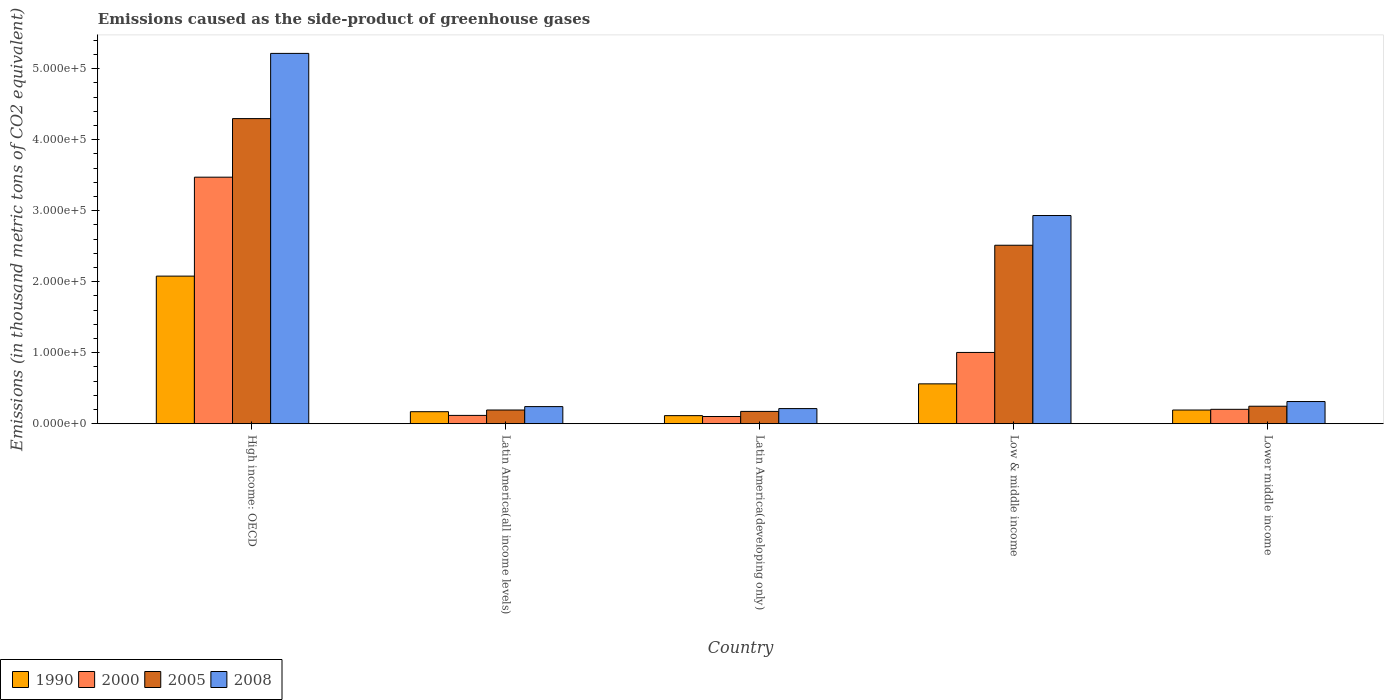How many bars are there on the 1st tick from the left?
Your response must be concise. 4. What is the label of the 3rd group of bars from the left?
Keep it short and to the point. Latin America(developing only). In how many cases, is the number of bars for a given country not equal to the number of legend labels?
Your answer should be very brief. 0. What is the emissions caused as the side-product of greenhouse gases in 2000 in Low & middle income?
Provide a succinct answer. 1.00e+05. Across all countries, what is the maximum emissions caused as the side-product of greenhouse gases in 2000?
Offer a very short reply. 3.47e+05. Across all countries, what is the minimum emissions caused as the side-product of greenhouse gases in 1990?
Keep it short and to the point. 1.14e+04. In which country was the emissions caused as the side-product of greenhouse gases in 1990 maximum?
Offer a terse response. High income: OECD. In which country was the emissions caused as the side-product of greenhouse gases in 1990 minimum?
Ensure brevity in your answer.  Latin America(developing only). What is the total emissions caused as the side-product of greenhouse gases in 2005 in the graph?
Offer a very short reply. 7.42e+05. What is the difference between the emissions caused as the side-product of greenhouse gases in 2005 in High income: OECD and that in Lower middle income?
Your answer should be very brief. 4.05e+05. What is the difference between the emissions caused as the side-product of greenhouse gases in 2008 in Latin America(developing only) and the emissions caused as the side-product of greenhouse gases in 2005 in High income: OECD?
Your answer should be compact. -4.08e+05. What is the average emissions caused as the side-product of greenhouse gases in 2005 per country?
Give a very brief answer. 1.48e+05. What is the difference between the emissions caused as the side-product of greenhouse gases of/in 2005 and emissions caused as the side-product of greenhouse gases of/in 1990 in Latin America(developing only)?
Ensure brevity in your answer.  5959.2. What is the ratio of the emissions caused as the side-product of greenhouse gases in 1990 in Latin America(all income levels) to that in Low & middle income?
Your answer should be very brief. 0.3. Is the emissions caused as the side-product of greenhouse gases in 1990 in High income: OECD less than that in Latin America(all income levels)?
Provide a succinct answer. No. What is the difference between the highest and the second highest emissions caused as the side-product of greenhouse gases in 2005?
Provide a short and direct response. -2.27e+05. What is the difference between the highest and the lowest emissions caused as the side-product of greenhouse gases in 2008?
Provide a succinct answer. 5.00e+05. In how many countries, is the emissions caused as the side-product of greenhouse gases in 2005 greater than the average emissions caused as the side-product of greenhouse gases in 2005 taken over all countries?
Offer a terse response. 2. How many bars are there?
Keep it short and to the point. 20. Are all the bars in the graph horizontal?
Make the answer very short. No. What is the difference between two consecutive major ticks on the Y-axis?
Keep it short and to the point. 1.00e+05. Are the values on the major ticks of Y-axis written in scientific E-notation?
Ensure brevity in your answer.  Yes. Does the graph contain grids?
Provide a short and direct response. No. How many legend labels are there?
Provide a short and direct response. 4. What is the title of the graph?
Your response must be concise. Emissions caused as the side-product of greenhouse gases. What is the label or title of the X-axis?
Offer a very short reply. Country. What is the label or title of the Y-axis?
Offer a terse response. Emissions (in thousand metric tons of CO2 equivalent). What is the Emissions (in thousand metric tons of CO2 equivalent) of 1990 in High income: OECD?
Your answer should be compact. 2.08e+05. What is the Emissions (in thousand metric tons of CO2 equivalent) of 2000 in High income: OECD?
Offer a terse response. 3.47e+05. What is the Emissions (in thousand metric tons of CO2 equivalent) of 2005 in High income: OECD?
Keep it short and to the point. 4.30e+05. What is the Emissions (in thousand metric tons of CO2 equivalent) in 2008 in High income: OECD?
Give a very brief answer. 5.22e+05. What is the Emissions (in thousand metric tons of CO2 equivalent) of 1990 in Latin America(all income levels)?
Give a very brief answer. 1.70e+04. What is the Emissions (in thousand metric tons of CO2 equivalent) of 2000 in Latin America(all income levels)?
Offer a very short reply. 1.18e+04. What is the Emissions (in thousand metric tons of CO2 equivalent) in 2005 in Latin America(all income levels)?
Ensure brevity in your answer.  1.93e+04. What is the Emissions (in thousand metric tons of CO2 equivalent) in 2008 in Latin America(all income levels)?
Keep it short and to the point. 2.41e+04. What is the Emissions (in thousand metric tons of CO2 equivalent) in 1990 in Latin America(developing only)?
Your response must be concise. 1.14e+04. What is the Emissions (in thousand metric tons of CO2 equivalent) of 2000 in Latin America(developing only)?
Give a very brief answer. 1.02e+04. What is the Emissions (in thousand metric tons of CO2 equivalent) of 2005 in Latin America(developing only)?
Your response must be concise. 1.74e+04. What is the Emissions (in thousand metric tons of CO2 equivalent) of 2008 in Latin America(developing only)?
Your answer should be compact. 2.13e+04. What is the Emissions (in thousand metric tons of CO2 equivalent) of 1990 in Low & middle income?
Your response must be concise. 5.62e+04. What is the Emissions (in thousand metric tons of CO2 equivalent) of 2000 in Low & middle income?
Ensure brevity in your answer.  1.00e+05. What is the Emissions (in thousand metric tons of CO2 equivalent) of 2005 in Low & middle income?
Give a very brief answer. 2.51e+05. What is the Emissions (in thousand metric tons of CO2 equivalent) in 2008 in Low & middle income?
Provide a short and direct response. 2.93e+05. What is the Emissions (in thousand metric tons of CO2 equivalent) in 1990 in Lower middle income?
Provide a succinct answer. 1.93e+04. What is the Emissions (in thousand metric tons of CO2 equivalent) in 2000 in Lower middle income?
Provide a short and direct response. 2.03e+04. What is the Emissions (in thousand metric tons of CO2 equivalent) in 2005 in Lower middle income?
Your response must be concise. 2.47e+04. What is the Emissions (in thousand metric tons of CO2 equivalent) of 2008 in Lower middle income?
Give a very brief answer. 3.13e+04. Across all countries, what is the maximum Emissions (in thousand metric tons of CO2 equivalent) of 1990?
Give a very brief answer. 2.08e+05. Across all countries, what is the maximum Emissions (in thousand metric tons of CO2 equivalent) of 2000?
Your answer should be very brief. 3.47e+05. Across all countries, what is the maximum Emissions (in thousand metric tons of CO2 equivalent) of 2005?
Provide a succinct answer. 4.30e+05. Across all countries, what is the maximum Emissions (in thousand metric tons of CO2 equivalent) of 2008?
Ensure brevity in your answer.  5.22e+05. Across all countries, what is the minimum Emissions (in thousand metric tons of CO2 equivalent) in 1990?
Give a very brief answer. 1.14e+04. Across all countries, what is the minimum Emissions (in thousand metric tons of CO2 equivalent) in 2000?
Ensure brevity in your answer.  1.02e+04. Across all countries, what is the minimum Emissions (in thousand metric tons of CO2 equivalent) of 2005?
Keep it short and to the point. 1.74e+04. Across all countries, what is the minimum Emissions (in thousand metric tons of CO2 equivalent) in 2008?
Make the answer very short. 2.13e+04. What is the total Emissions (in thousand metric tons of CO2 equivalent) in 1990 in the graph?
Your response must be concise. 3.12e+05. What is the total Emissions (in thousand metric tons of CO2 equivalent) in 2000 in the graph?
Offer a very short reply. 4.90e+05. What is the total Emissions (in thousand metric tons of CO2 equivalent) of 2005 in the graph?
Your answer should be compact. 7.42e+05. What is the total Emissions (in thousand metric tons of CO2 equivalent) of 2008 in the graph?
Your response must be concise. 8.92e+05. What is the difference between the Emissions (in thousand metric tons of CO2 equivalent) in 1990 in High income: OECD and that in Latin America(all income levels)?
Offer a very short reply. 1.91e+05. What is the difference between the Emissions (in thousand metric tons of CO2 equivalent) of 2000 in High income: OECD and that in Latin America(all income levels)?
Your response must be concise. 3.35e+05. What is the difference between the Emissions (in thousand metric tons of CO2 equivalent) of 2005 in High income: OECD and that in Latin America(all income levels)?
Offer a very short reply. 4.10e+05. What is the difference between the Emissions (in thousand metric tons of CO2 equivalent) of 2008 in High income: OECD and that in Latin America(all income levels)?
Provide a succinct answer. 4.97e+05. What is the difference between the Emissions (in thousand metric tons of CO2 equivalent) in 1990 in High income: OECD and that in Latin America(developing only)?
Your response must be concise. 1.96e+05. What is the difference between the Emissions (in thousand metric tons of CO2 equivalent) in 2000 in High income: OECD and that in Latin America(developing only)?
Give a very brief answer. 3.37e+05. What is the difference between the Emissions (in thousand metric tons of CO2 equivalent) in 2005 in High income: OECD and that in Latin America(developing only)?
Your response must be concise. 4.12e+05. What is the difference between the Emissions (in thousand metric tons of CO2 equivalent) in 2008 in High income: OECD and that in Latin America(developing only)?
Provide a short and direct response. 5.00e+05. What is the difference between the Emissions (in thousand metric tons of CO2 equivalent) of 1990 in High income: OECD and that in Low & middle income?
Give a very brief answer. 1.52e+05. What is the difference between the Emissions (in thousand metric tons of CO2 equivalent) in 2000 in High income: OECD and that in Low & middle income?
Provide a succinct answer. 2.47e+05. What is the difference between the Emissions (in thousand metric tons of CO2 equivalent) in 2005 in High income: OECD and that in Low & middle income?
Make the answer very short. 1.78e+05. What is the difference between the Emissions (in thousand metric tons of CO2 equivalent) of 2008 in High income: OECD and that in Low & middle income?
Ensure brevity in your answer.  2.28e+05. What is the difference between the Emissions (in thousand metric tons of CO2 equivalent) of 1990 in High income: OECD and that in Lower middle income?
Your answer should be very brief. 1.89e+05. What is the difference between the Emissions (in thousand metric tons of CO2 equivalent) of 2000 in High income: OECD and that in Lower middle income?
Offer a terse response. 3.27e+05. What is the difference between the Emissions (in thousand metric tons of CO2 equivalent) of 2005 in High income: OECD and that in Lower middle income?
Your answer should be compact. 4.05e+05. What is the difference between the Emissions (in thousand metric tons of CO2 equivalent) of 2008 in High income: OECD and that in Lower middle income?
Offer a terse response. 4.90e+05. What is the difference between the Emissions (in thousand metric tons of CO2 equivalent) in 1990 in Latin America(all income levels) and that in Latin America(developing only)?
Give a very brief answer. 5561.3. What is the difference between the Emissions (in thousand metric tons of CO2 equivalent) of 2000 in Latin America(all income levels) and that in Latin America(developing only)?
Offer a very short reply. 1569.5. What is the difference between the Emissions (in thousand metric tons of CO2 equivalent) in 2005 in Latin America(all income levels) and that in Latin America(developing only)?
Offer a very short reply. 1982.4. What is the difference between the Emissions (in thousand metric tons of CO2 equivalent) of 2008 in Latin America(all income levels) and that in Latin America(developing only)?
Provide a short and direct response. 2806.6. What is the difference between the Emissions (in thousand metric tons of CO2 equivalent) in 1990 in Latin America(all income levels) and that in Low & middle income?
Ensure brevity in your answer.  -3.92e+04. What is the difference between the Emissions (in thousand metric tons of CO2 equivalent) of 2000 in Latin America(all income levels) and that in Low & middle income?
Give a very brief answer. -8.86e+04. What is the difference between the Emissions (in thousand metric tons of CO2 equivalent) of 2005 in Latin America(all income levels) and that in Low & middle income?
Your answer should be very brief. -2.32e+05. What is the difference between the Emissions (in thousand metric tons of CO2 equivalent) of 2008 in Latin America(all income levels) and that in Low & middle income?
Provide a short and direct response. -2.69e+05. What is the difference between the Emissions (in thousand metric tons of CO2 equivalent) in 1990 in Latin America(all income levels) and that in Lower middle income?
Your response must be concise. -2340.6. What is the difference between the Emissions (in thousand metric tons of CO2 equivalent) of 2000 in Latin America(all income levels) and that in Lower middle income?
Offer a very short reply. -8559. What is the difference between the Emissions (in thousand metric tons of CO2 equivalent) of 2005 in Latin America(all income levels) and that in Lower middle income?
Offer a very short reply. -5307.3. What is the difference between the Emissions (in thousand metric tons of CO2 equivalent) of 2008 in Latin America(all income levels) and that in Lower middle income?
Ensure brevity in your answer.  -7127.6. What is the difference between the Emissions (in thousand metric tons of CO2 equivalent) in 1990 in Latin America(developing only) and that in Low & middle income?
Your answer should be compact. -4.48e+04. What is the difference between the Emissions (in thousand metric tons of CO2 equivalent) of 2000 in Latin America(developing only) and that in Low & middle income?
Your answer should be compact. -9.02e+04. What is the difference between the Emissions (in thousand metric tons of CO2 equivalent) in 2005 in Latin America(developing only) and that in Low & middle income?
Make the answer very short. -2.34e+05. What is the difference between the Emissions (in thousand metric tons of CO2 equivalent) of 2008 in Latin America(developing only) and that in Low & middle income?
Provide a short and direct response. -2.72e+05. What is the difference between the Emissions (in thousand metric tons of CO2 equivalent) of 1990 in Latin America(developing only) and that in Lower middle income?
Your answer should be compact. -7901.9. What is the difference between the Emissions (in thousand metric tons of CO2 equivalent) in 2000 in Latin America(developing only) and that in Lower middle income?
Offer a terse response. -1.01e+04. What is the difference between the Emissions (in thousand metric tons of CO2 equivalent) of 2005 in Latin America(developing only) and that in Lower middle income?
Ensure brevity in your answer.  -7289.7. What is the difference between the Emissions (in thousand metric tons of CO2 equivalent) in 2008 in Latin America(developing only) and that in Lower middle income?
Your answer should be very brief. -9934.2. What is the difference between the Emissions (in thousand metric tons of CO2 equivalent) of 1990 in Low & middle income and that in Lower middle income?
Your answer should be very brief. 3.69e+04. What is the difference between the Emissions (in thousand metric tons of CO2 equivalent) in 2000 in Low & middle income and that in Lower middle income?
Make the answer very short. 8.01e+04. What is the difference between the Emissions (in thousand metric tons of CO2 equivalent) in 2005 in Low & middle income and that in Lower middle income?
Your response must be concise. 2.27e+05. What is the difference between the Emissions (in thousand metric tons of CO2 equivalent) in 2008 in Low & middle income and that in Lower middle income?
Offer a terse response. 2.62e+05. What is the difference between the Emissions (in thousand metric tons of CO2 equivalent) in 1990 in High income: OECD and the Emissions (in thousand metric tons of CO2 equivalent) in 2000 in Latin America(all income levels)?
Your response must be concise. 1.96e+05. What is the difference between the Emissions (in thousand metric tons of CO2 equivalent) in 1990 in High income: OECD and the Emissions (in thousand metric tons of CO2 equivalent) in 2005 in Latin America(all income levels)?
Provide a succinct answer. 1.89e+05. What is the difference between the Emissions (in thousand metric tons of CO2 equivalent) of 1990 in High income: OECD and the Emissions (in thousand metric tons of CO2 equivalent) of 2008 in Latin America(all income levels)?
Your answer should be compact. 1.84e+05. What is the difference between the Emissions (in thousand metric tons of CO2 equivalent) of 2000 in High income: OECD and the Emissions (in thousand metric tons of CO2 equivalent) of 2005 in Latin America(all income levels)?
Your response must be concise. 3.28e+05. What is the difference between the Emissions (in thousand metric tons of CO2 equivalent) of 2000 in High income: OECD and the Emissions (in thousand metric tons of CO2 equivalent) of 2008 in Latin America(all income levels)?
Ensure brevity in your answer.  3.23e+05. What is the difference between the Emissions (in thousand metric tons of CO2 equivalent) in 2005 in High income: OECD and the Emissions (in thousand metric tons of CO2 equivalent) in 2008 in Latin America(all income levels)?
Your response must be concise. 4.06e+05. What is the difference between the Emissions (in thousand metric tons of CO2 equivalent) of 1990 in High income: OECD and the Emissions (in thousand metric tons of CO2 equivalent) of 2000 in Latin America(developing only)?
Provide a succinct answer. 1.98e+05. What is the difference between the Emissions (in thousand metric tons of CO2 equivalent) of 1990 in High income: OECD and the Emissions (in thousand metric tons of CO2 equivalent) of 2005 in Latin America(developing only)?
Offer a terse response. 1.91e+05. What is the difference between the Emissions (in thousand metric tons of CO2 equivalent) in 1990 in High income: OECD and the Emissions (in thousand metric tons of CO2 equivalent) in 2008 in Latin America(developing only)?
Give a very brief answer. 1.87e+05. What is the difference between the Emissions (in thousand metric tons of CO2 equivalent) in 2000 in High income: OECD and the Emissions (in thousand metric tons of CO2 equivalent) in 2005 in Latin America(developing only)?
Your response must be concise. 3.30e+05. What is the difference between the Emissions (in thousand metric tons of CO2 equivalent) in 2000 in High income: OECD and the Emissions (in thousand metric tons of CO2 equivalent) in 2008 in Latin America(developing only)?
Your answer should be very brief. 3.26e+05. What is the difference between the Emissions (in thousand metric tons of CO2 equivalent) in 2005 in High income: OECD and the Emissions (in thousand metric tons of CO2 equivalent) in 2008 in Latin America(developing only)?
Your answer should be compact. 4.08e+05. What is the difference between the Emissions (in thousand metric tons of CO2 equivalent) of 1990 in High income: OECD and the Emissions (in thousand metric tons of CO2 equivalent) of 2000 in Low & middle income?
Give a very brief answer. 1.07e+05. What is the difference between the Emissions (in thousand metric tons of CO2 equivalent) of 1990 in High income: OECD and the Emissions (in thousand metric tons of CO2 equivalent) of 2005 in Low & middle income?
Offer a terse response. -4.35e+04. What is the difference between the Emissions (in thousand metric tons of CO2 equivalent) of 1990 in High income: OECD and the Emissions (in thousand metric tons of CO2 equivalent) of 2008 in Low & middle income?
Offer a terse response. -8.53e+04. What is the difference between the Emissions (in thousand metric tons of CO2 equivalent) of 2000 in High income: OECD and the Emissions (in thousand metric tons of CO2 equivalent) of 2005 in Low & middle income?
Provide a short and direct response. 9.58e+04. What is the difference between the Emissions (in thousand metric tons of CO2 equivalent) in 2000 in High income: OECD and the Emissions (in thousand metric tons of CO2 equivalent) in 2008 in Low & middle income?
Offer a terse response. 5.40e+04. What is the difference between the Emissions (in thousand metric tons of CO2 equivalent) of 2005 in High income: OECD and the Emissions (in thousand metric tons of CO2 equivalent) of 2008 in Low & middle income?
Your answer should be very brief. 1.36e+05. What is the difference between the Emissions (in thousand metric tons of CO2 equivalent) of 1990 in High income: OECD and the Emissions (in thousand metric tons of CO2 equivalent) of 2000 in Lower middle income?
Your answer should be compact. 1.88e+05. What is the difference between the Emissions (in thousand metric tons of CO2 equivalent) in 1990 in High income: OECD and the Emissions (in thousand metric tons of CO2 equivalent) in 2005 in Lower middle income?
Provide a succinct answer. 1.83e+05. What is the difference between the Emissions (in thousand metric tons of CO2 equivalent) of 1990 in High income: OECD and the Emissions (in thousand metric tons of CO2 equivalent) of 2008 in Lower middle income?
Your response must be concise. 1.77e+05. What is the difference between the Emissions (in thousand metric tons of CO2 equivalent) of 2000 in High income: OECD and the Emissions (in thousand metric tons of CO2 equivalent) of 2005 in Lower middle income?
Offer a terse response. 3.23e+05. What is the difference between the Emissions (in thousand metric tons of CO2 equivalent) of 2000 in High income: OECD and the Emissions (in thousand metric tons of CO2 equivalent) of 2008 in Lower middle income?
Give a very brief answer. 3.16e+05. What is the difference between the Emissions (in thousand metric tons of CO2 equivalent) of 2005 in High income: OECD and the Emissions (in thousand metric tons of CO2 equivalent) of 2008 in Lower middle income?
Your answer should be compact. 3.98e+05. What is the difference between the Emissions (in thousand metric tons of CO2 equivalent) of 1990 in Latin America(all income levels) and the Emissions (in thousand metric tons of CO2 equivalent) of 2000 in Latin America(developing only)?
Provide a short and direct response. 6780. What is the difference between the Emissions (in thousand metric tons of CO2 equivalent) of 1990 in Latin America(all income levels) and the Emissions (in thousand metric tons of CO2 equivalent) of 2005 in Latin America(developing only)?
Give a very brief answer. -397.9. What is the difference between the Emissions (in thousand metric tons of CO2 equivalent) of 1990 in Latin America(all income levels) and the Emissions (in thousand metric tons of CO2 equivalent) of 2008 in Latin America(developing only)?
Your response must be concise. -4367. What is the difference between the Emissions (in thousand metric tons of CO2 equivalent) of 2000 in Latin America(all income levels) and the Emissions (in thousand metric tons of CO2 equivalent) of 2005 in Latin America(developing only)?
Make the answer very short. -5608.4. What is the difference between the Emissions (in thousand metric tons of CO2 equivalent) of 2000 in Latin America(all income levels) and the Emissions (in thousand metric tons of CO2 equivalent) of 2008 in Latin America(developing only)?
Your response must be concise. -9577.5. What is the difference between the Emissions (in thousand metric tons of CO2 equivalent) in 2005 in Latin America(all income levels) and the Emissions (in thousand metric tons of CO2 equivalent) in 2008 in Latin America(developing only)?
Provide a short and direct response. -1986.7. What is the difference between the Emissions (in thousand metric tons of CO2 equivalent) in 1990 in Latin America(all income levels) and the Emissions (in thousand metric tons of CO2 equivalent) in 2000 in Low & middle income?
Provide a short and direct response. -8.34e+04. What is the difference between the Emissions (in thousand metric tons of CO2 equivalent) in 1990 in Latin America(all income levels) and the Emissions (in thousand metric tons of CO2 equivalent) in 2005 in Low & middle income?
Your response must be concise. -2.34e+05. What is the difference between the Emissions (in thousand metric tons of CO2 equivalent) in 1990 in Latin America(all income levels) and the Emissions (in thousand metric tons of CO2 equivalent) in 2008 in Low & middle income?
Offer a very short reply. -2.76e+05. What is the difference between the Emissions (in thousand metric tons of CO2 equivalent) of 2000 in Latin America(all income levels) and the Emissions (in thousand metric tons of CO2 equivalent) of 2005 in Low & middle income?
Your response must be concise. -2.40e+05. What is the difference between the Emissions (in thousand metric tons of CO2 equivalent) in 2000 in Latin America(all income levels) and the Emissions (in thousand metric tons of CO2 equivalent) in 2008 in Low & middle income?
Offer a terse response. -2.81e+05. What is the difference between the Emissions (in thousand metric tons of CO2 equivalent) in 2005 in Latin America(all income levels) and the Emissions (in thousand metric tons of CO2 equivalent) in 2008 in Low & middle income?
Provide a succinct answer. -2.74e+05. What is the difference between the Emissions (in thousand metric tons of CO2 equivalent) in 1990 in Latin America(all income levels) and the Emissions (in thousand metric tons of CO2 equivalent) in 2000 in Lower middle income?
Your response must be concise. -3348.5. What is the difference between the Emissions (in thousand metric tons of CO2 equivalent) of 1990 in Latin America(all income levels) and the Emissions (in thousand metric tons of CO2 equivalent) of 2005 in Lower middle income?
Keep it short and to the point. -7687.6. What is the difference between the Emissions (in thousand metric tons of CO2 equivalent) of 1990 in Latin America(all income levels) and the Emissions (in thousand metric tons of CO2 equivalent) of 2008 in Lower middle income?
Provide a short and direct response. -1.43e+04. What is the difference between the Emissions (in thousand metric tons of CO2 equivalent) of 2000 in Latin America(all income levels) and the Emissions (in thousand metric tons of CO2 equivalent) of 2005 in Lower middle income?
Your answer should be compact. -1.29e+04. What is the difference between the Emissions (in thousand metric tons of CO2 equivalent) of 2000 in Latin America(all income levels) and the Emissions (in thousand metric tons of CO2 equivalent) of 2008 in Lower middle income?
Provide a short and direct response. -1.95e+04. What is the difference between the Emissions (in thousand metric tons of CO2 equivalent) in 2005 in Latin America(all income levels) and the Emissions (in thousand metric tons of CO2 equivalent) in 2008 in Lower middle income?
Your response must be concise. -1.19e+04. What is the difference between the Emissions (in thousand metric tons of CO2 equivalent) of 1990 in Latin America(developing only) and the Emissions (in thousand metric tons of CO2 equivalent) of 2000 in Low & middle income?
Your answer should be very brief. -8.90e+04. What is the difference between the Emissions (in thousand metric tons of CO2 equivalent) in 1990 in Latin America(developing only) and the Emissions (in thousand metric tons of CO2 equivalent) in 2005 in Low & middle income?
Your answer should be very brief. -2.40e+05. What is the difference between the Emissions (in thousand metric tons of CO2 equivalent) of 1990 in Latin America(developing only) and the Emissions (in thousand metric tons of CO2 equivalent) of 2008 in Low & middle income?
Offer a very short reply. -2.82e+05. What is the difference between the Emissions (in thousand metric tons of CO2 equivalent) of 2000 in Latin America(developing only) and the Emissions (in thousand metric tons of CO2 equivalent) of 2005 in Low & middle income?
Offer a terse response. -2.41e+05. What is the difference between the Emissions (in thousand metric tons of CO2 equivalent) in 2000 in Latin America(developing only) and the Emissions (in thousand metric tons of CO2 equivalent) in 2008 in Low & middle income?
Give a very brief answer. -2.83e+05. What is the difference between the Emissions (in thousand metric tons of CO2 equivalent) in 2005 in Latin America(developing only) and the Emissions (in thousand metric tons of CO2 equivalent) in 2008 in Low & middle income?
Make the answer very short. -2.76e+05. What is the difference between the Emissions (in thousand metric tons of CO2 equivalent) of 1990 in Latin America(developing only) and the Emissions (in thousand metric tons of CO2 equivalent) of 2000 in Lower middle income?
Give a very brief answer. -8909.8. What is the difference between the Emissions (in thousand metric tons of CO2 equivalent) of 1990 in Latin America(developing only) and the Emissions (in thousand metric tons of CO2 equivalent) of 2005 in Lower middle income?
Ensure brevity in your answer.  -1.32e+04. What is the difference between the Emissions (in thousand metric tons of CO2 equivalent) of 1990 in Latin America(developing only) and the Emissions (in thousand metric tons of CO2 equivalent) of 2008 in Lower middle income?
Your answer should be very brief. -1.99e+04. What is the difference between the Emissions (in thousand metric tons of CO2 equivalent) of 2000 in Latin America(developing only) and the Emissions (in thousand metric tons of CO2 equivalent) of 2005 in Lower middle income?
Keep it short and to the point. -1.45e+04. What is the difference between the Emissions (in thousand metric tons of CO2 equivalent) of 2000 in Latin America(developing only) and the Emissions (in thousand metric tons of CO2 equivalent) of 2008 in Lower middle income?
Ensure brevity in your answer.  -2.11e+04. What is the difference between the Emissions (in thousand metric tons of CO2 equivalent) of 2005 in Latin America(developing only) and the Emissions (in thousand metric tons of CO2 equivalent) of 2008 in Lower middle income?
Offer a terse response. -1.39e+04. What is the difference between the Emissions (in thousand metric tons of CO2 equivalent) in 1990 in Low & middle income and the Emissions (in thousand metric tons of CO2 equivalent) in 2000 in Lower middle income?
Give a very brief answer. 3.59e+04. What is the difference between the Emissions (in thousand metric tons of CO2 equivalent) of 1990 in Low & middle income and the Emissions (in thousand metric tons of CO2 equivalent) of 2005 in Lower middle income?
Your response must be concise. 3.15e+04. What is the difference between the Emissions (in thousand metric tons of CO2 equivalent) in 1990 in Low & middle income and the Emissions (in thousand metric tons of CO2 equivalent) in 2008 in Lower middle income?
Provide a short and direct response. 2.49e+04. What is the difference between the Emissions (in thousand metric tons of CO2 equivalent) in 2000 in Low & middle income and the Emissions (in thousand metric tons of CO2 equivalent) in 2005 in Lower middle income?
Your answer should be compact. 7.57e+04. What is the difference between the Emissions (in thousand metric tons of CO2 equivalent) in 2000 in Low & middle income and the Emissions (in thousand metric tons of CO2 equivalent) in 2008 in Lower middle income?
Offer a very short reply. 6.91e+04. What is the difference between the Emissions (in thousand metric tons of CO2 equivalent) in 2005 in Low & middle income and the Emissions (in thousand metric tons of CO2 equivalent) in 2008 in Lower middle income?
Your answer should be compact. 2.20e+05. What is the average Emissions (in thousand metric tons of CO2 equivalent) in 1990 per country?
Provide a short and direct response. 6.23e+04. What is the average Emissions (in thousand metric tons of CO2 equivalent) of 2000 per country?
Provide a short and direct response. 9.80e+04. What is the average Emissions (in thousand metric tons of CO2 equivalent) in 2005 per country?
Provide a short and direct response. 1.48e+05. What is the average Emissions (in thousand metric tons of CO2 equivalent) of 2008 per country?
Your answer should be very brief. 1.78e+05. What is the difference between the Emissions (in thousand metric tons of CO2 equivalent) of 1990 and Emissions (in thousand metric tons of CO2 equivalent) of 2000 in High income: OECD?
Your answer should be very brief. -1.39e+05. What is the difference between the Emissions (in thousand metric tons of CO2 equivalent) of 1990 and Emissions (in thousand metric tons of CO2 equivalent) of 2005 in High income: OECD?
Your answer should be compact. -2.22e+05. What is the difference between the Emissions (in thousand metric tons of CO2 equivalent) in 1990 and Emissions (in thousand metric tons of CO2 equivalent) in 2008 in High income: OECD?
Offer a terse response. -3.14e+05. What is the difference between the Emissions (in thousand metric tons of CO2 equivalent) in 2000 and Emissions (in thousand metric tons of CO2 equivalent) in 2005 in High income: OECD?
Ensure brevity in your answer.  -8.25e+04. What is the difference between the Emissions (in thousand metric tons of CO2 equivalent) of 2000 and Emissions (in thousand metric tons of CO2 equivalent) of 2008 in High income: OECD?
Your response must be concise. -1.74e+05. What is the difference between the Emissions (in thousand metric tons of CO2 equivalent) of 2005 and Emissions (in thousand metric tons of CO2 equivalent) of 2008 in High income: OECD?
Provide a succinct answer. -9.18e+04. What is the difference between the Emissions (in thousand metric tons of CO2 equivalent) of 1990 and Emissions (in thousand metric tons of CO2 equivalent) of 2000 in Latin America(all income levels)?
Offer a terse response. 5210.5. What is the difference between the Emissions (in thousand metric tons of CO2 equivalent) in 1990 and Emissions (in thousand metric tons of CO2 equivalent) in 2005 in Latin America(all income levels)?
Keep it short and to the point. -2380.3. What is the difference between the Emissions (in thousand metric tons of CO2 equivalent) in 1990 and Emissions (in thousand metric tons of CO2 equivalent) in 2008 in Latin America(all income levels)?
Your answer should be compact. -7173.6. What is the difference between the Emissions (in thousand metric tons of CO2 equivalent) of 2000 and Emissions (in thousand metric tons of CO2 equivalent) of 2005 in Latin America(all income levels)?
Keep it short and to the point. -7590.8. What is the difference between the Emissions (in thousand metric tons of CO2 equivalent) of 2000 and Emissions (in thousand metric tons of CO2 equivalent) of 2008 in Latin America(all income levels)?
Keep it short and to the point. -1.24e+04. What is the difference between the Emissions (in thousand metric tons of CO2 equivalent) of 2005 and Emissions (in thousand metric tons of CO2 equivalent) of 2008 in Latin America(all income levels)?
Your answer should be compact. -4793.3. What is the difference between the Emissions (in thousand metric tons of CO2 equivalent) of 1990 and Emissions (in thousand metric tons of CO2 equivalent) of 2000 in Latin America(developing only)?
Offer a terse response. 1218.7. What is the difference between the Emissions (in thousand metric tons of CO2 equivalent) in 1990 and Emissions (in thousand metric tons of CO2 equivalent) in 2005 in Latin America(developing only)?
Provide a succinct answer. -5959.2. What is the difference between the Emissions (in thousand metric tons of CO2 equivalent) of 1990 and Emissions (in thousand metric tons of CO2 equivalent) of 2008 in Latin America(developing only)?
Offer a very short reply. -9928.3. What is the difference between the Emissions (in thousand metric tons of CO2 equivalent) of 2000 and Emissions (in thousand metric tons of CO2 equivalent) of 2005 in Latin America(developing only)?
Keep it short and to the point. -7177.9. What is the difference between the Emissions (in thousand metric tons of CO2 equivalent) of 2000 and Emissions (in thousand metric tons of CO2 equivalent) of 2008 in Latin America(developing only)?
Keep it short and to the point. -1.11e+04. What is the difference between the Emissions (in thousand metric tons of CO2 equivalent) of 2005 and Emissions (in thousand metric tons of CO2 equivalent) of 2008 in Latin America(developing only)?
Provide a succinct answer. -3969.1. What is the difference between the Emissions (in thousand metric tons of CO2 equivalent) in 1990 and Emissions (in thousand metric tons of CO2 equivalent) in 2000 in Low & middle income?
Ensure brevity in your answer.  -4.42e+04. What is the difference between the Emissions (in thousand metric tons of CO2 equivalent) in 1990 and Emissions (in thousand metric tons of CO2 equivalent) in 2005 in Low & middle income?
Keep it short and to the point. -1.95e+05. What is the difference between the Emissions (in thousand metric tons of CO2 equivalent) of 1990 and Emissions (in thousand metric tons of CO2 equivalent) of 2008 in Low & middle income?
Offer a very short reply. -2.37e+05. What is the difference between the Emissions (in thousand metric tons of CO2 equivalent) in 2000 and Emissions (in thousand metric tons of CO2 equivalent) in 2005 in Low & middle income?
Your response must be concise. -1.51e+05. What is the difference between the Emissions (in thousand metric tons of CO2 equivalent) in 2000 and Emissions (in thousand metric tons of CO2 equivalent) in 2008 in Low & middle income?
Keep it short and to the point. -1.93e+05. What is the difference between the Emissions (in thousand metric tons of CO2 equivalent) of 2005 and Emissions (in thousand metric tons of CO2 equivalent) of 2008 in Low & middle income?
Provide a short and direct response. -4.19e+04. What is the difference between the Emissions (in thousand metric tons of CO2 equivalent) in 1990 and Emissions (in thousand metric tons of CO2 equivalent) in 2000 in Lower middle income?
Your response must be concise. -1007.9. What is the difference between the Emissions (in thousand metric tons of CO2 equivalent) in 1990 and Emissions (in thousand metric tons of CO2 equivalent) in 2005 in Lower middle income?
Your response must be concise. -5347. What is the difference between the Emissions (in thousand metric tons of CO2 equivalent) in 1990 and Emissions (in thousand metric tons of CO2 equivalent) in 2008 in Lower middle income?
Provide a succinct answer. -1.20e+04. What is the difference between the Emissions (in thousand metric tons of CO2 equivalent) in 2000 and Emissions (in thousand metric tons of CO2 equivalent) in 2005 in Lower middle income?
Your answer should be compact. -4339.1. What is the difference between the Emissions (in thousand metric tons of CO2 equivalent) of 2000 and Emissions (in thousand metric tons of CO2 equivalent) of 2008 in Lower middle income?
Keep it short and to the point. -1.10e+04. What is the difference between the Emissions (in thousand metric tons of CO2 equivalent) in 2005 and Emissions (in thousand metric tons of CO2 equivalent) in 2008 in Lower middle income?
Offer a very short reply. -6613.6. What is the ratio of the Emissions (in thousand metric tons of CO2 equivalent) of 1990 in High income: OECD to that in Latin America(all income levels)?
Provide a short and direct response. 12.25. What is the ratio of the Emissions (in thousand metric tons of CO2 equivalent) in 2000 in High income: OECD to that in Latin America(all income levels)?
Keep it short and to the point. 29.54. What is the ratio of the Emissions (in thousand metric tons of CO2 equivalent) in 2005 in High income: OECD to that in Latin America(all income levels)?
Provide a short and direct response. 22.21. What is the ratio of the Emissions (in thousand metric tons of CO2 equivalent) in 2008 in High income: OECD to that in Latin America(all income levels)?
Provide a succinct answer. 21.61. What is the ratio of the Emissions (in thousand metric tons of CO2 equivalent) of 1990 in High income: OECD to that in Latin America(developing only)?
Provide a succinct answer. 18.23. What is the ratio of the Emissions (in thousand metric tons of CO2 equivalent) in 2000 in High income: OECD to that in Latin America(developing only)?
Provide a short and direct response. 34.09. What is the ratio of the Emissions (in thousand metric tons of CO2 equivalent) in 2005 in High income: OECD to that in Latin America(developing only)?
Your answer should be very brief. 24.75. What is the ratio of the Emissions (in thousand metric tons of CO2 equivalent) in 2008 in High income: OECD to that in Latin America(developing only)?
Make the answer very short. 24.45. What is the ratio of the Emissions (in thousand metric tons of CO2 equivalent) of 1990 in High income: OECD to that in Low & middle income?
Keep it short and to the point. 3.7. What is the ratio of the Emissions (in thousand metric tons of CO2 equivalent) of 2000 in High income: OECD to that in Low & middle income?
Ensure brevity in your answer.  3.46. What is the ratio of the Emissions (in thousand metric tons of CO2 equivalent) of 2005 in High income: OECD to that in Low & middle income?
Offer a terse response. 1.71. What is the ratio of the Emissions (in thousand metric tons of CO2 equivalent) of 2008 in High income: OECD to that in Low & middle income?
Offer a terse response. 1.78. What is the ratio of the Emissions (in thousand metric tons of CO2 equivalent) of 1990 in High income: OECD to that in Lower middle income?
Offer a terse response. 10.77. What is the ratio of the Emissions (in thousand metric tons of CO2 equivalent) of 2000 in High income: OECD to that in Lower middle income?
Give a very brief answer. 17.09. What is the ratio of the Emissions (in thousand metric tons of CO2 equivalent) in 2005 in High income: OECD to that in Lower middle income?
Your answer should be compact. 17.43. What is the ratio of the Emissions (in thousand metric tons of CO2 equivalent) of 2008 in High income: OECD to that in Lower middle income?
Ensure brevity in your answer.  16.68. What is the ratio of the Emissions (in thousand metric tons of CO2 equivalent) in 1990 in Latin America(all income levels) to that in Latin America(developing only)?
Keep it short and to the point. 1.49. What is the ratio of the Emissions (in thousand metric tons of CO2 equivalent) in 2000 in Latin America(all income levels) to that in Latin America(developing only)?
Offer a very short reply. 1.15. What is the ratio of the Emissions (in thousand metric tons of CO2 equivalent) in 2005 in Latin America(all income levels) to that in Latin America(developing only)?
Offer a terse response. 1.11. What is the ratio of the Emissions (in thousand metric tons of CO2 equivalent) in 2008 in Latin America(all income levels) to that in Latin America(developing only)?
Offer a terse response. 1.13. What is the ratio of the Emissions (in thousand metric tons of CO2 equivalent) in 1990 in Latin America(all income levels) to that in Low & middle income?
Provide a short and direct response. 0.3. What is the ratio of the Emissions (in thousand metric tons of CO2 equivalent) in 2000 in Latin America(all income levels) to that in Low & middle income?
Ensure brevity in your answer.  0.12. What is the ratio of the Emissions (in thousand metric tons of CO2 equivalent) of 2005 in Latin America(all income levels) to that in Low & middle income?
Give a very brief answer. 0.08. What is the ratio of the Emissions (in thousand metric tons of CO2 equivalent) of 2008 in Latin America(all income levels) to that in Low & middle income?
Offer a very short reply. 0.08. What is the ratio of the Emissions (in thousand metric tons of CO2 equivalent) in 1990 in Latin America(all income levels) to that in Lower middle income?
Offer a terse response. 0.88. What is the ratio of the Emissions (in thousand metric tons of CO2 equivalent) of 2000 in Latin America(all income levels) to that in Lower middle income?
Give a very brief answer. 0.58. What is the ratio of the Emissions (in thousand metric tons of CO2 equivalent) in 2005 in Latin America(all income levels) to that in Lower middle income?
Provide a short and direct response. 0.78. What is the ratio of the Emissions (in thousand metric tons of CO2 equivalent) in 2008 in Latin America(all income levels) to that in Lower middle income?
Keep it short and to the point. 0.77. What is the ratio of the Emissions (in thousand metric tons of CO2 equivalent) of 1990 in Latin America(developing only) to that in Low & middle income?
Give a very brief answer. 0.2. What is the ratio of the Emissions (in thousand metric tons of CO2 equivalent) of 2000 in Latin America(developing only) to that in Low & middle income?
Offer a very short reply. 0.1. What is the ratio of the Emissions (in thousand metric tons of CO2 equivalent) of 2005 in Latin America(developing only) to that in Low & middle income?
Offer a very short reply. 0.07. What is the ratio of the Emissions (in thousand metric tons of CO2 equivalent) of 2008 in Latin America(developing only) to that in Low & middle income?
Provide a succinct answer. 0.07. What is the ratio of the Emissions (in thousand metric tons of CO2 equivalent) in 1990 in Latin America(developing only) to that in Lower middle income?
Ensure brevity in your answer.  0.59. What is the ratio of the Emissions (in thousand metric tons of CO2 equivalent) of 2000 in Latin America(developing only) to that in Lower middle income?
Ensure brevity in your answer.  0.5. What is the ratio of the Emissions (in thousand metric tons of CO2 equivalent) of 2005 in Latin America(developing only) to that in Lower middle income?
Your response must be concise. 0.7. What is the ratio of the Emissions (in thousand metric tons of CO2 equivalent) of 2008 in Latin America(developing only) to that in Lower middle income?
Make the answer very short. 0.68. What is the ratio of the Emissions (in thousand metric tons of CO2 equivalent) in 1990 in Low & middle income to that in Lower middle income?
Offer a very short reply. 2.91. What is the ratio of the Emissions (in thousand metric tons of CO2 equivalent) in 2000 in Low & middle income to that in Lower middle income?
Keep it short and to the point. 4.94. What is the ratio of the Emissions (in thousand metric tons of CO2 equivalent) in 2005 in Low & middle income to that in Lower middle income?
Your answer should be compact. 10.2. What is the ratio of the Emissions (in thousand metric tons of CO2 equivalent) of 2008 in Low & middle income to that in Lower middle income?
Provide a short and direct response. 9.38. What is the difference between the highest and the second highest Emissions (in thousand metric tons of CO2 equivalent) of 1990?
Offer a very short reply. 1.52e+05. What is the difference between the highest and the second highest Emissions (in thousand metric tons of CO2 equivalent) of 2000?
Provide a succinct answer. 2.47e+05. What is the difference between the highest and the second highest Emissions (in thousand metric tons of CO2 equivalent) of 2005?
Offer a very short reply. 1.78e+05. What is the difference between the highest and the second highest Emissions (in thousand metric tons of CO2 equivalent) of 2008?
Provide a short and direct response. 2.28e+05. What is the difference between the highest and the lowest Emissions (in thousand metric tons of CO2 equivalent) of 1990?
Make the answer very short. 1.96e+05. What is the difference between the highest and the lowest Emissions (in thousand metric tons of CO2 equivalent) of 2000?
Keep it short and to the point. 3.37e+05. What is the difference between the highest and the lowest Emissions (in thousand metric tons of CO2 equivalent) in 2005?
Provide a short and direct response. 4.12e+05. What is the difference between the highest and the lowest Emissions (in thousand metric tons of CO2 equivalent) in 2008?
Provide a succinct answer. 5.00e+05. 